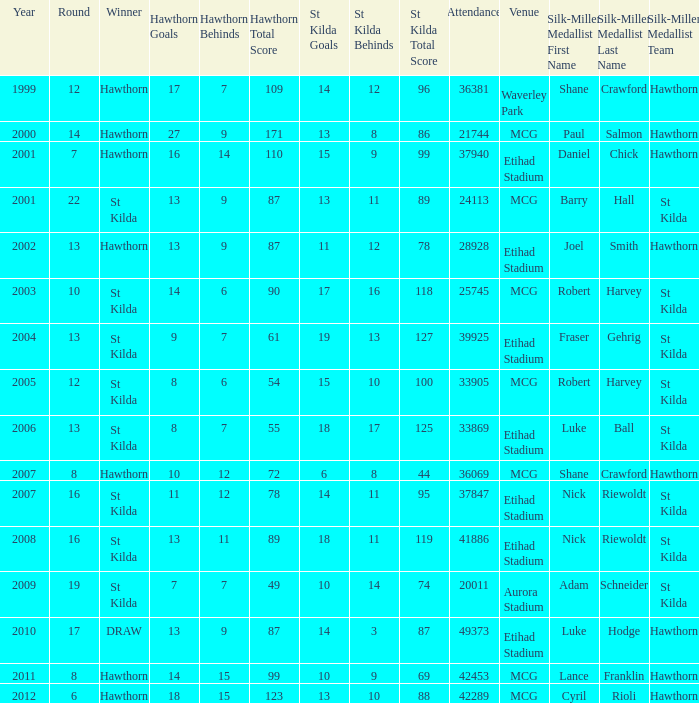What is the attendance when the hawthorn score is 18.15.123? 42289.0. 